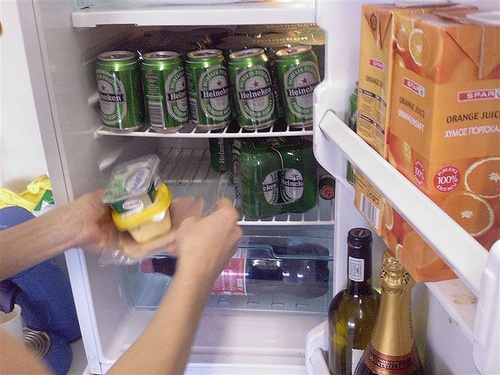Describe the objects in this image and their specific colors. I can see refrigerator in lightgray, darkgray, gray, and black tones, people in lightgray, tan, gray, and darkgray tones, bottle in lightgray, gray, navy, black, and violet tones, bottle in lightgray, black, gray, and olive tones, and bottle in lightgray, gray, olive, maroon, and brown tones in this image. 